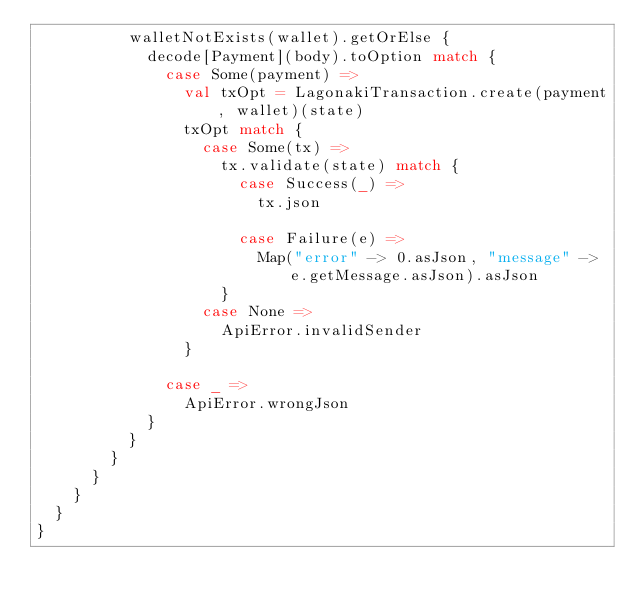<code> <loc_0><loc_0><loc_500><loc_500><_Scala_>          walletNotExists(wallet).getOrElse {
            decode[Payment](body).toOption match {
              case Some(payment) =>
                val txOpt = LagonakiTransaction.create(payment, wallet)(state)
                txOpt match {
                  case Some(tx) =>
                    tx.validate(state) match {
                      case Success(_) =>
                        tx.json

                      case Failure(e) =>
                        Map("error" -> 0.asJson, "message" -> e.getMessage.asJson).asJson
                    }
                  case None =>
                    ApiError.invalidSender
                }

              case _ =>
                ApiError.wrongJson
            }
          }
        }
      }
    }
  }
}</code> 